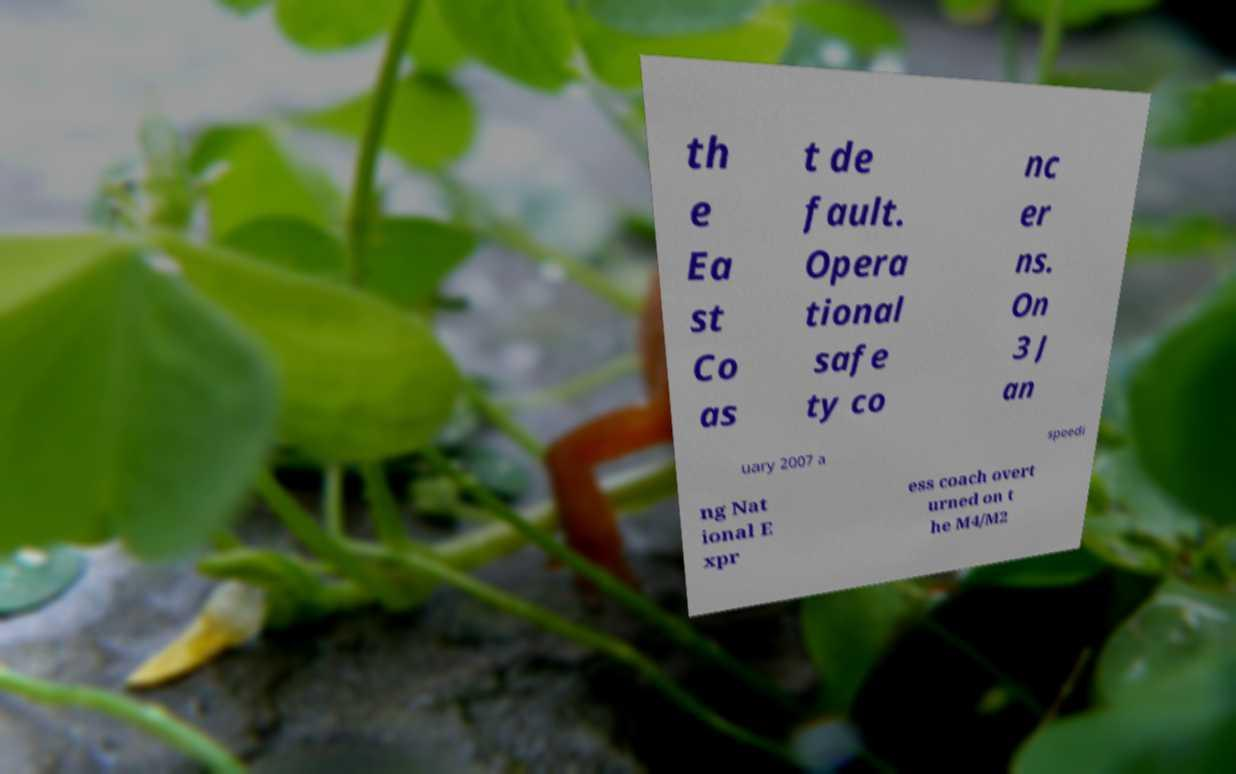There's text embedded in this image that I need extracted. Can you transcribe it verbatim? th e Ea st Co as t de fault. Opera tional safe ty co nc er ns. On 3 J an uary 2007 a speedi ng Nat ional E xpr ess coach overt urned on t he M4/M2 